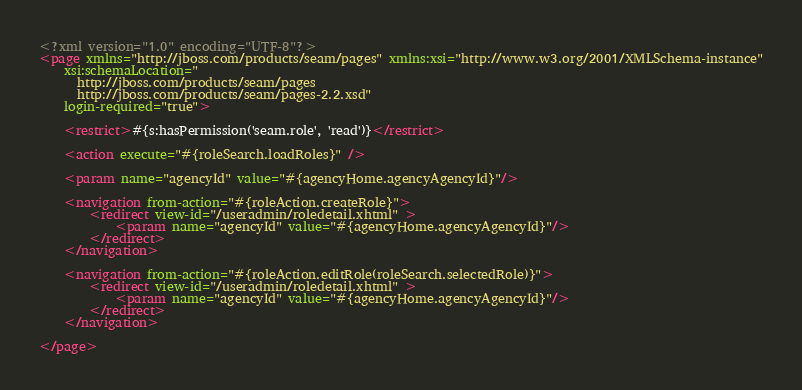Convert code to text. <code><loc_0><loc_0><loc_500><loc_500><_XML_><?xml version="1.0" encoding="UTF-8"?>
<page xmlns="http://jboss.com/products/seam/pages" xmlns:xsi="http://www.w3.org/2001/XMLSchema-instance"
	xsi:schemaLocation="
      http://jboss.com/products/seam/pages
      http://jboss.com/products/seam/pages-2.2.xsd"
	login-required="true">

	<restrict>#{s:hasPermission('seam.role', 'read')}</restrict>

	<action execute="#{roleSearch.loadRoles}" />

	<param name="agencyId" value="#{agencyHome.agencyAgencyId}"/>

	<navigation from-action="#{roleAction.createRole}">
		<redirect view-id="/useradmin/roledetail.xhtml" >
			<param name="agencyId" value="#{agencyHome.agencyAgencyId}"/>
		</redirect>
	</navigation>

	<navigation from-action="#{roleAction.editRole(roleSearch.selectedRole)}">
		<redirect view-id="/useradmin/roledetail.xhtml" >
			<param name="agencyId" value="#{agencyHome.agencyAgencyId}"/>
		</redirect>
	</navigation>

</page>
</code> 